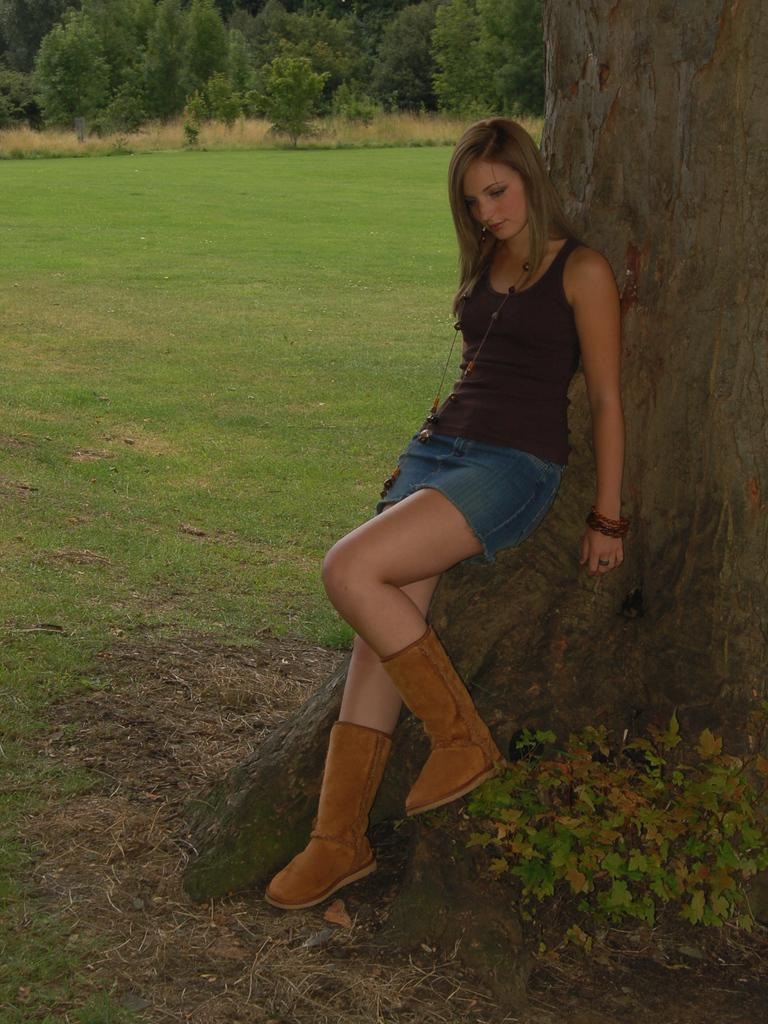What type of vegetation is present in the image? There is grass and trees in the image. What is the woman in the image wearing? The woman is wearing a black dress and pants. Can you describe the trees in the image? There is a tree stem visible in the image. What type of copper material can be seen in the image? There is no copper material present in the image. Is there a picture of a surprise in the image? There is no picture or surprise depicted in the image. 